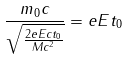Convert formula to latex. <formula><loc_0><loc_0><loc_500><loc_500>\frac { m _ { 0 } c } { \sqrt { \frac { 2 e E c t _ { 0 } } { M c ^ { 2 } } } } = e E t _ { 0 }</formula> 